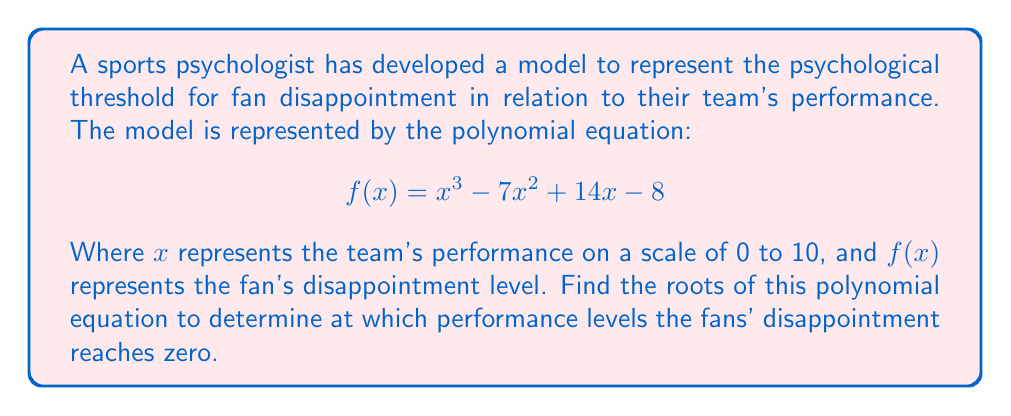Show me your answer to this math problem. To find the roots of the polynomial equation, we need to solve $f(x) = 0$. Let's approach this step-by-step:

1) We start with the equation: $x^3 - 7x^2 + 14x - 8 = 0$

2) This is a cubic equation. One way to solve it is to guess one root and then use polynomial long division to reduce it to a quadratic equation.

3) By inspection or trial and error, we can find that $x = 1$ is a root. (When $x = 1$, $1^3 - 7(1)^2 + 14(1) - 8 = 1 - 7 + 14 - 8 = 0$)

4) Now, let's use polynomial long division to divide $x^3 - 7x^2 + 14x - 8$ by $(x - 1)$:

   $x^3 - 7x^2 + 14x - 8 = (x - 1)(x^2 - 6x + 8)$

5) So, our equation becomes: $(x - 1)(x^2 - 6x + 8) = 0$

6) By the zero product property, either $x - 1 = 0$ or $x^2 - 6x + 8 = 0$

7) From $x - 1 = 0$, we get $x = 1$ (which we already knew)

8) For $x^2 - 6x + 8 = 0$, we can solve using the quadratic formula:
   
   $x = \frac{-b \pm \sqrt{b^2 - 4ac}}{2a}$

   Where $a = 1$, $b = -6$, and $c = 8$

9) Plugging in these values:

   $x = \frac{6 \pm \sqrt{36 - 32}}{2} = \frac{6 \pm \sqrt{4}}{2} = \frac{6 \pm 2}{2}$

10) This gives us: $x = \frac{6 + 2}{2} = 4$ or $x = \frac{6 - 2}{2} = 2$

Therefore, the roots of the equation are $x = 1$, $x = 2$, and $x = 4$.
Answer: $x = 1$, $x = 2$, $x = 4$ 